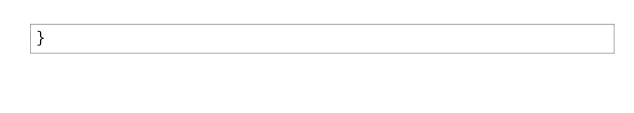Convert code to text. <code><loc_0><loc_0><loc_500><loc_500><_Scala_>}
</code> 